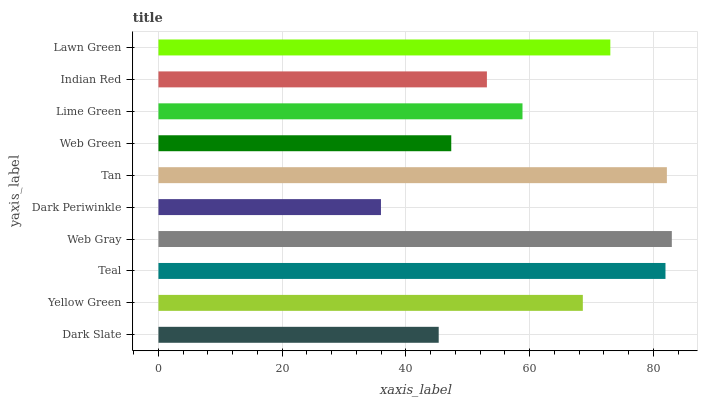Is Dark Periwinkle the minimum?
Answer yes or no. Yes. Is Web Gray the maximum?
Answer yes or no. Yes. Is Yellow Green the minimum?
Answer yes or no. No. Is Yellow Green the maximum?
Answer yes or no. No. Is Yellow Green greater than Dark Slate?
Answer yes or no. Yes. Is Dark Slate less than Yellow Green?
Answer yes or no. Yes. Is Dark Slate greater than Yellow Green?
Answer yes or no. No. Is Yellow Green less than Dark Slate?
Answer yes or no. No. Is Yellow Green the high median?
Answer yes or no. Yes. Is Lime Green the low median?
Answer yes or no. Yes. Is Tan the high median?
Answer yes or no. No. Is Web Gray the low median?
Answer yes or no. No. 